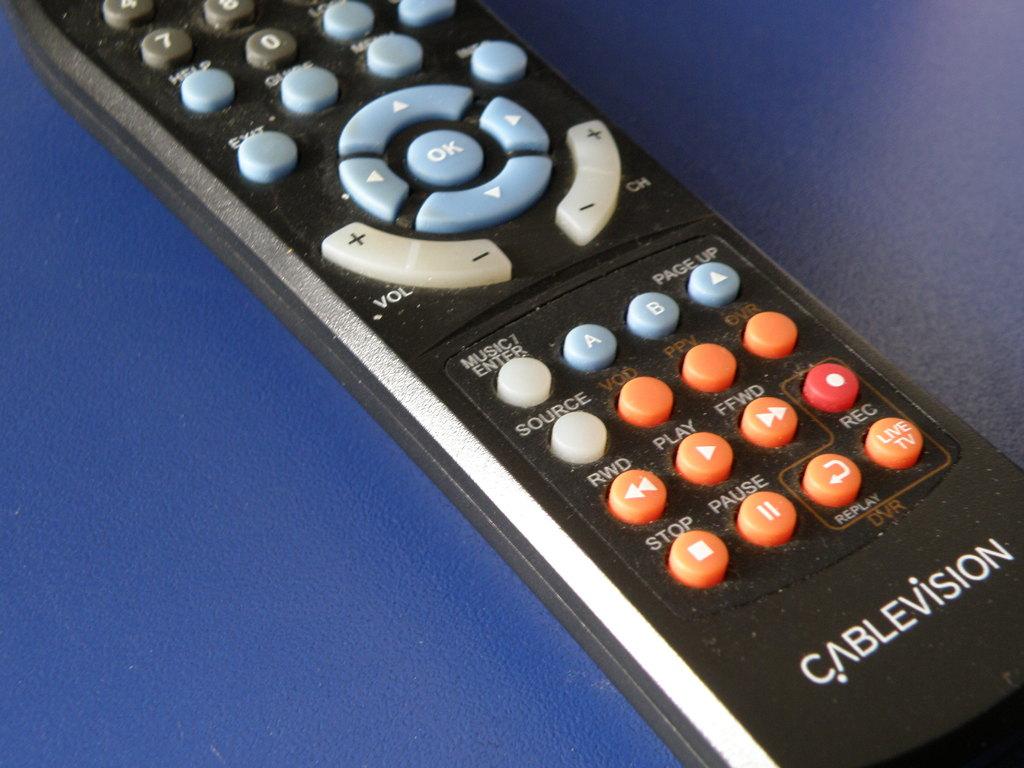What kind of vision is the company?
Your answer should be compact. Cablevision. What function does the button on the bottom right perform?
Ensure brevity in your answer.  Live tv. 